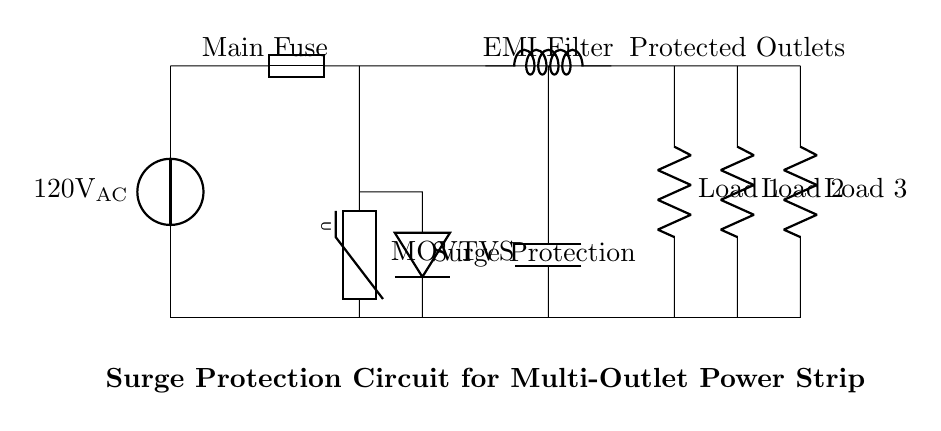What is the main voltage in this circuit? The circuit is powered by a voltage source marked as one hundred twenty volts AC, which indicates the main voltage provided to the circuit.
Answer: one hundred twenty volts AC What component is used for surge protection? The surge protection is implemented using a varistor, specifically specified as an MOV in this circuit. This component is essential to absorb voltage spikes.
Answer: MOV How many outlet loads are represented in the circuit? The circuit diagram includes three outlet loads represented by three resistors labeled as Load 1, Load 2, and Load 3, indicating multiple devices can be connected.
Answer: three What type of filter is shown in the circuit? The circuit includes an EMI filter, conspicuously labeled above the component, indicating that it is designed to mitigate electromagnetic interference.
Answer: EMI filter What is the purpose of the fuse in this circuit? The fuse functions as a protective element that disconnects the circuit in case of overcurrent conditions, thus protecting connected devices from damage.
Answer: protection Which component is placed after the surge protection? Following the surge protection, the circuit includes a TVS diode, which is positioned to handle any remaining transient voltages after the MOV absorbs the initial surge.
Answer: TVS diode 